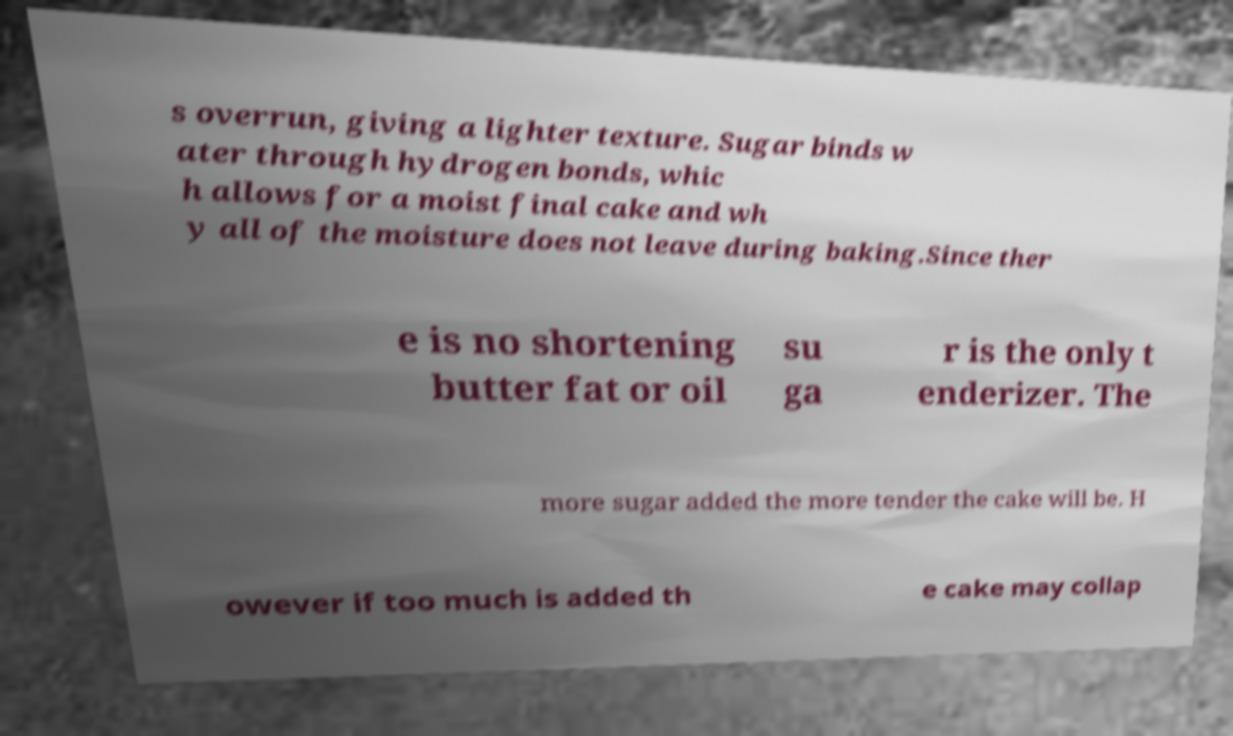For documentation purposes, I need the text within this image transcribed. Could you provide that? s overrun, giving a lighter texture. Sugar binds w ater through hydrogen bonds, whic h allows for a moist final cake and wh y all of the moisture does not leave during baking.Since ther e is no shortening butter fat or oil su ga r is the only t enderizer. The more sugar added the more tender the cake will be. H owever if too much is added th e cake may collap 